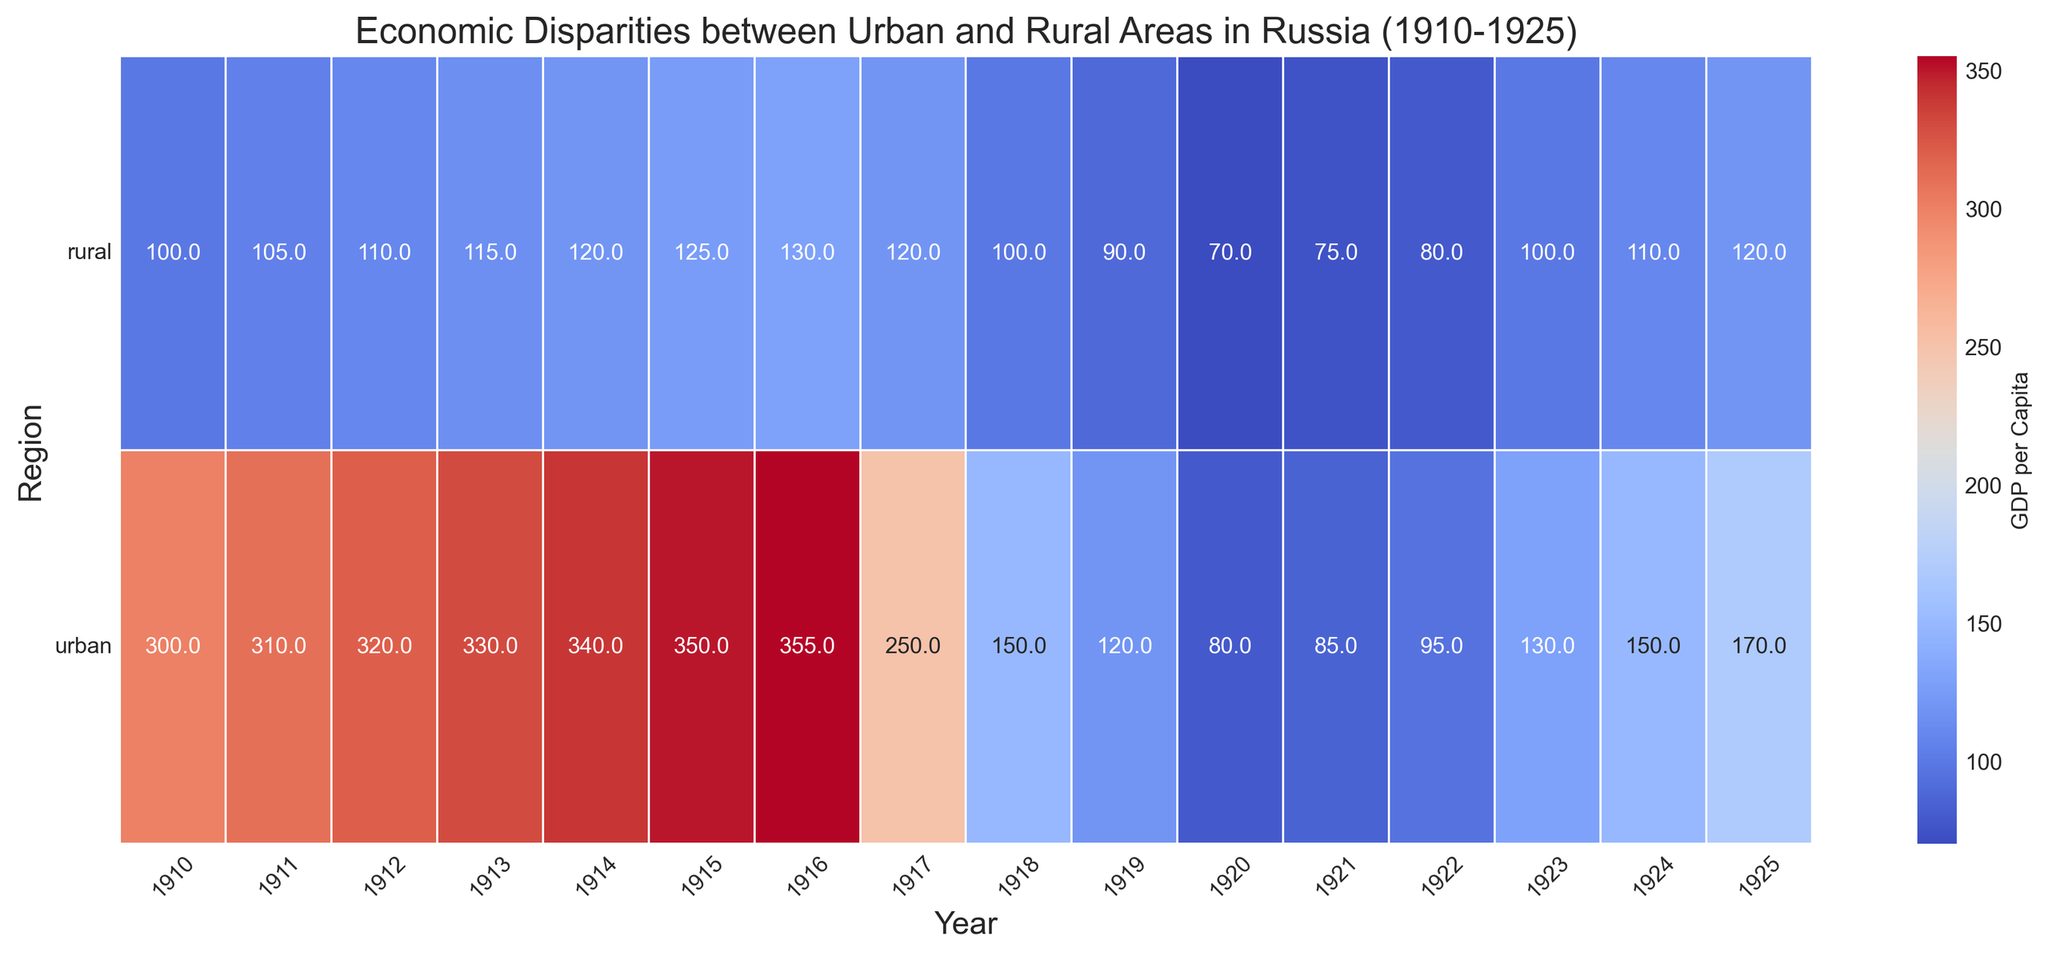What year shows the highest economic disparity between urban and rural areas? To determine the year with the highest economic disparity, we need to look for the largest difference between the GDP per capita in urban and rural regions for each year. The largest difference is seen in 1916, where the GDP per capita in urban areas is 355 and in rural areas is 130, giving a disparity of 225.
Answer: 1916 Which year had the lowest GDP per capita for urban areas, and what was the value? To find this, we need to locate the lowest value in the urban row of the heatmap. The year 1920 has the lowest GDP per capita for urban areas at 80.
Answer: 1920, 80 In what year did rural areas first surpass a GDP per capita of 120? Observing the heatmap, the first year where the rural GDP per capita exceeds 120 is in 1925, where it reaches 120.
Answer: 1925 By how much did the GDP per capita in rural areas change from 1917 to 1920? We need to subtract the GDP per capita of rural areas in 1917 (120) from the value in 1920 (70). The change is 120 - 70 = 50.
Answer: 50 Which region experienced more fluctuation in GDP per capita over the years, urban or rural? To answer this, we observe the consistency of changes in the colors of the heatmap for both regions. The urban region had drastic fluctuations, especially after 1917, with significant dips and increases in GDP per capita, showing higher fluctuation than the rural areas.
Answer: urban What was the GDP per capita for both regions in 1913, and which was higher? From the heatmap, in 1913, the urban GDP per capita was 330, and the rural GDP per capita was 115. The urban GDP per capita was higher.
Answer: 330 (urban), urban On average, how did the rural GDP per capita change from 1910 to 1925 in five-year increments? To solve this, we take the average GDP per capita for rural areas at 1910 (100), 1915 (125), 1920 (70), and 1925 (120): (100 + 125 + 70 + 120) / 4 = 103.75.
Answer: 103.75 Was there any year after the October Revolution (1917) where rural GDP per capita was higher than urban GDP per capita? By scanning the heatmap after 1917, in no year does the rural GDP per capita exceed the urban GDP per capita. Thus, there was no such year.
Answer: No What trend do we see in urban GDP per capita from 1910 to 1925 immediately following the October Revolution? From the heatmap, there is a noticeable decline in urban GDP per capita post-1917, reaching the lowest point in 1920, followed by a gradual recovery through to 1925.
Answer: Decline, then recovery During which years did the rural GDP per capita remain static, and at what value? Looking at the heatmap, the rural GDP per capita remains static from 1916 to 1917 at 120.
Answer: 1916-1917, 120 